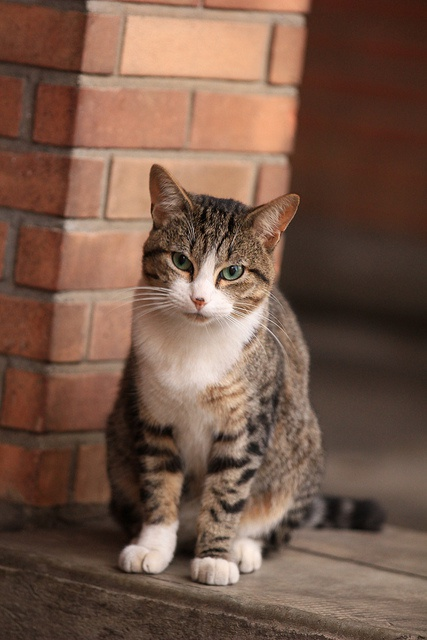Describe the objects in this image and their specific colors. I can see a cat in maroon, gray, black, and tan tones in this image. 